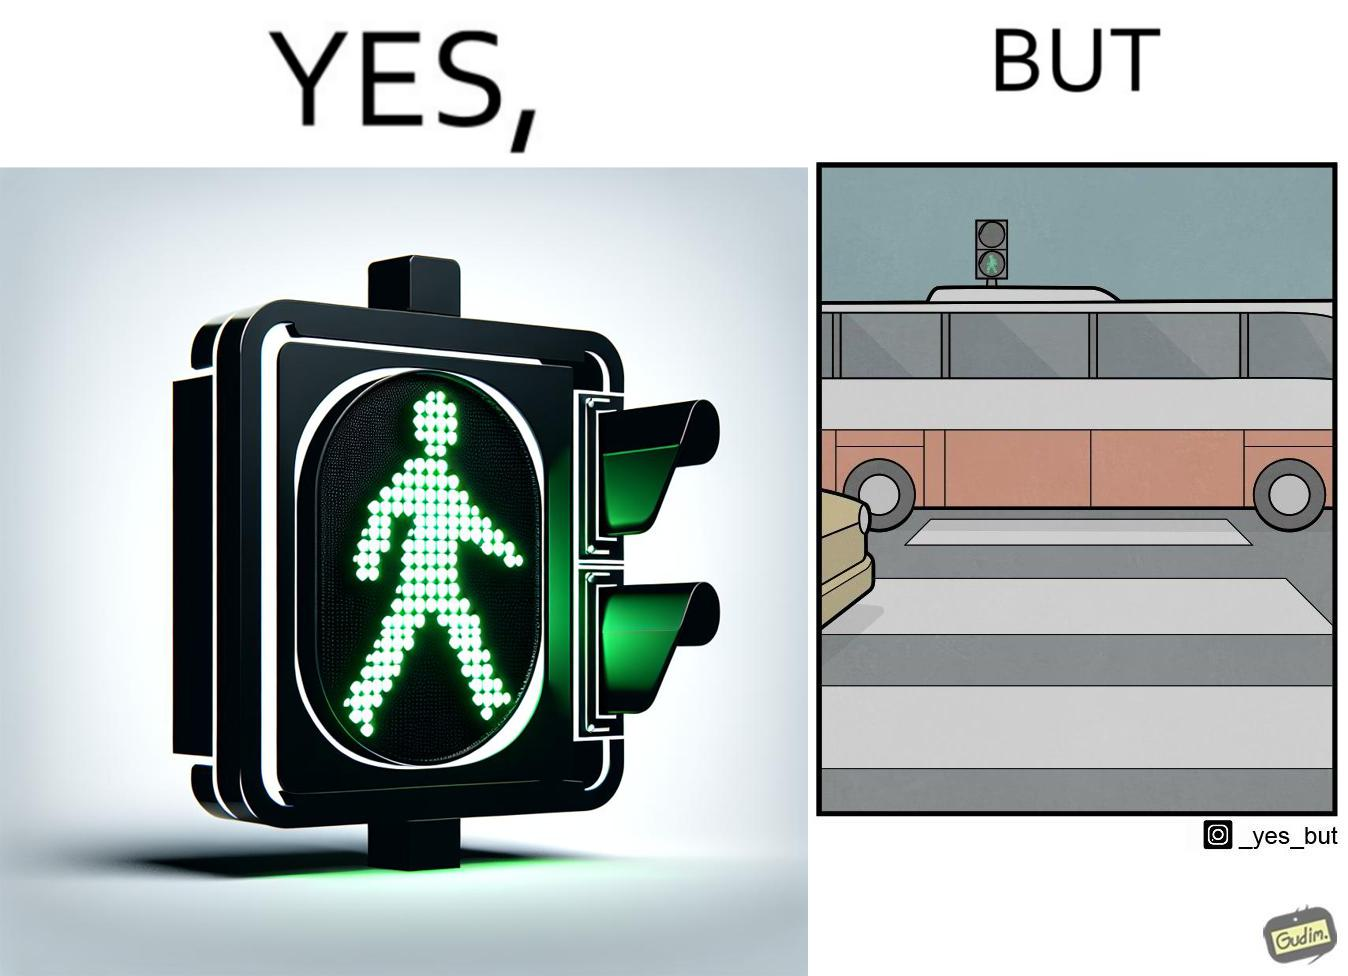Explain the humor or irony in this image. The image is ironic, because even when the signal is green for the pedestrians but they can't cross the road because of the vehicles standing on the zebra crossing 